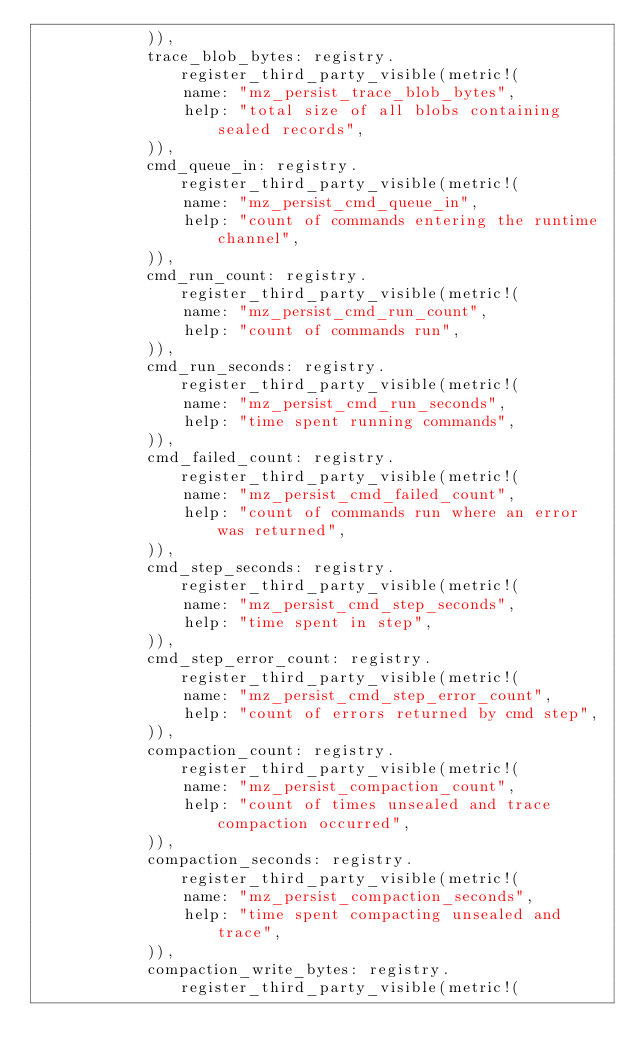Convert code to text. <code><loc_0><loc_0><loc_500><loc_500><_Rust_>            )),
            trace_blob_bytes: registry.register_third_party_visible(metric!(
                name: "mz_persist_trace_blob_bytes",
                help: "total size of all blobs containing sealed records",
            )),
            cmd_queue_in: registry.register_third_party_visible(metric!(
                name: "mz_persist_cmd_queue_in",
                help: "count of commands entering the runtime channel",
            )),
            cmd_run_count: registry.register_third_party_visible(metric!(
                name: "mz_persist_cmd_run_count",
                help: "count of commands run",
            )),
            cmd_run_seconds: registry.register_third_party_visible(metric!(
                name: "mz_persist_cmd_run_seconds",
                help: "time spent running commands",
            )),
            cmd_failed_count: registry.register_third_party_visible(metric!(
                name: "mz_persist_cmd_failed_count",
                help: "count of commands run where an error was returned",
            )),
            cmd_step_seconds: registry.register_third_party_visible(metric!(
                name: "mz_persist_cmd_step_seconds",
                help: "time spent in step",
            )),
            cmd_step_error_count: registry.register_third_party_visible(metric!(
                name: "mz_persist_cmd_step_error_count",
                help: "count of errors returned by cmd step",
            )),
            compaction_count: registry.register_third_party_visible(metric!(
                name: "mz_persist_compaction_count",
                help: "count of times unsealed and trace compaction occurred",
            )),
            compaction_seconds: registry.register_third_party_visible(metric!(
                name: "mz_persist_compaction_seconds",
                help: "time spent compacting unsealed and trace",
            )),
            compaction_write_bytes: registry.register_third_party_visible(metric!(</code> 